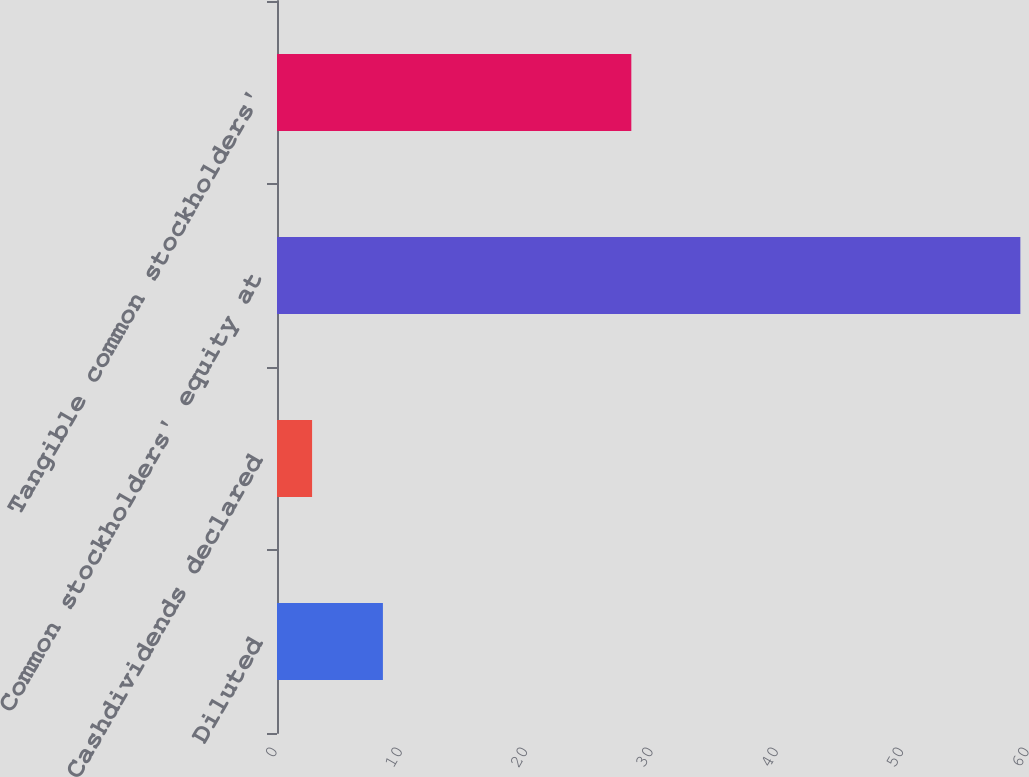Convert chart. <chart><loc_0><loc_0><loc_500><loc_500><bar_chart><fcel>Diluted<fcel>Cashdividends declared<fcel>Common stockholders' equity at<fcel>Tangible common stockholders'<nl><fcel>8.45<fcel>2.8<fcel>59.31<fcel>28.27<nl></chart> 